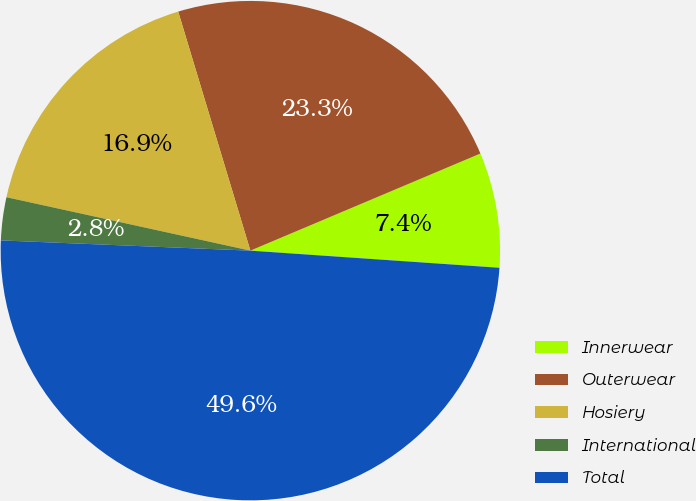Convert chart. <chart><loc_0><loc_0><loc_500><loc_500><pie_chart><fcel>Innerwear<fcel>Outerwear<fcel>Hosiery<fcel>International<fcel>Total<nl><fcel>7.45%<fcel>23.31%<fcel>16.9%<fcel>2.78%<fcel>49.56%<nl></chart> 